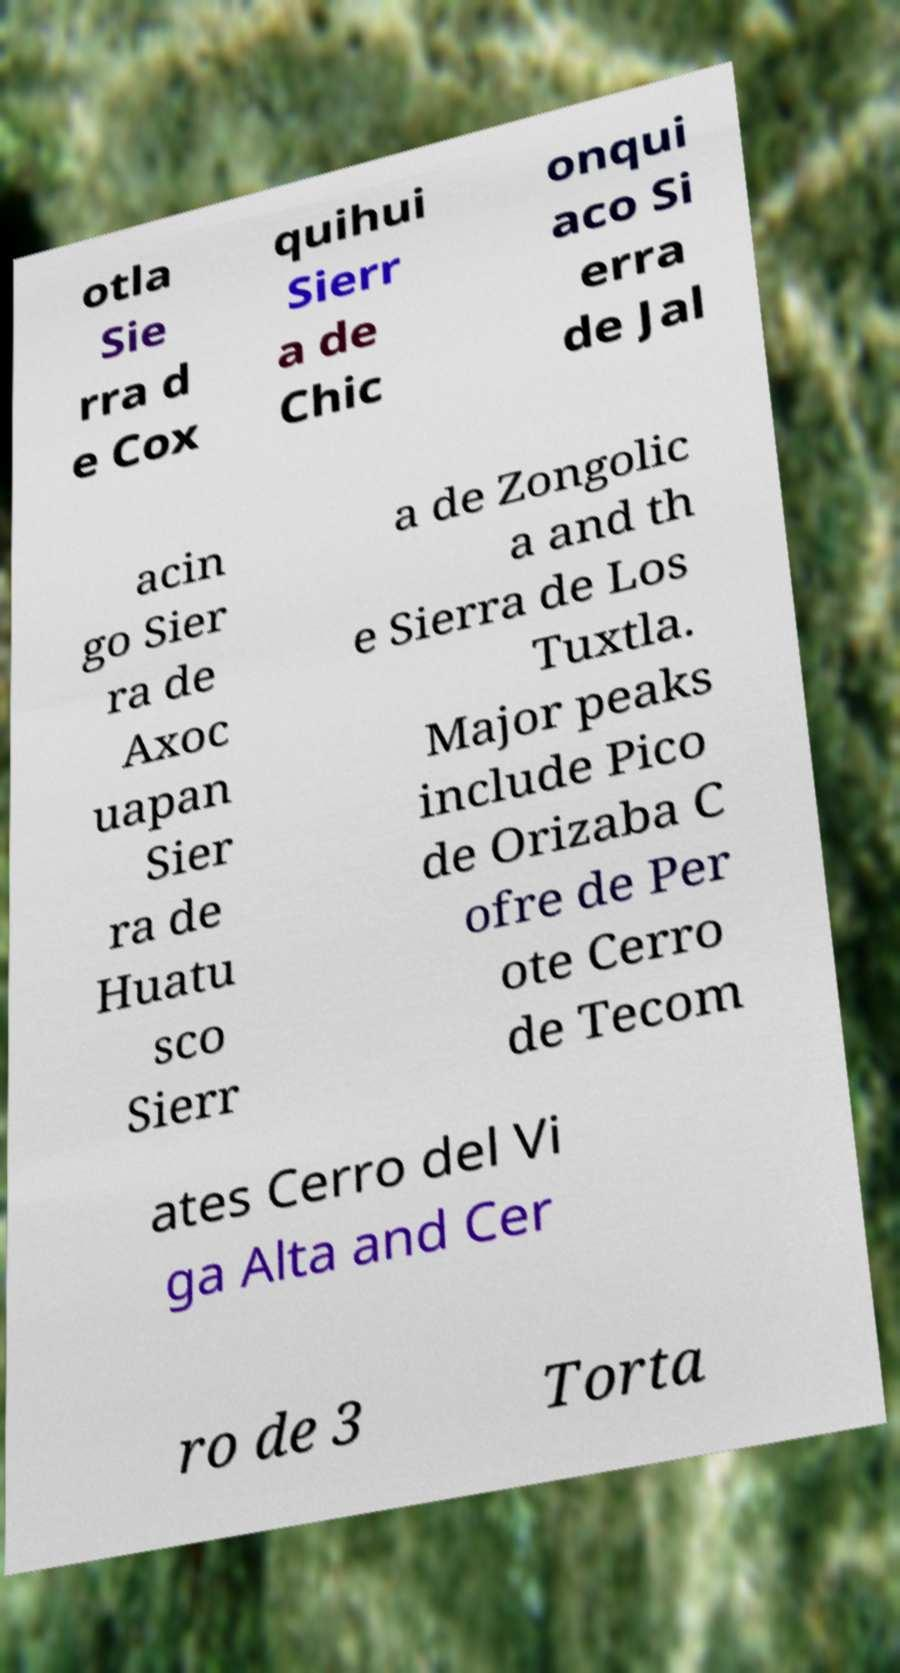For documentation purposes, I need the text within this image transcribed. Could you provide that? otla Sie rra d e Cox quihui Sierr a de Chic onqui aco Si erra de Jal acin go Sier ra de Axoc uapan Sier ra de Huatu sco Sierr a de Zongolic a and th e Sierra de Los Tuxtla. Major peaks include Pico de Orizaba C ofre de Per ote Cerro de Tecom ates Cerro del Vi ga Alta and Cer ro de 3 Torta 